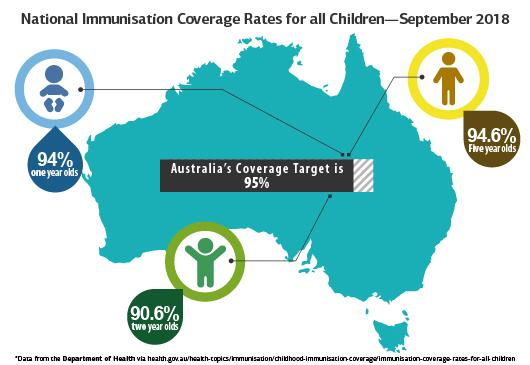Highlight a few significant elements in this photo. The age group of children with the highest immunisation coverage rate in September 2018 was five-year-olds, according to recent data. The immunization coverage rate for children in September 2018 was 90.6%. According to the data collected in September 2018, the age group of children with the lowest immunisation coverage rate is two-year-olds. 